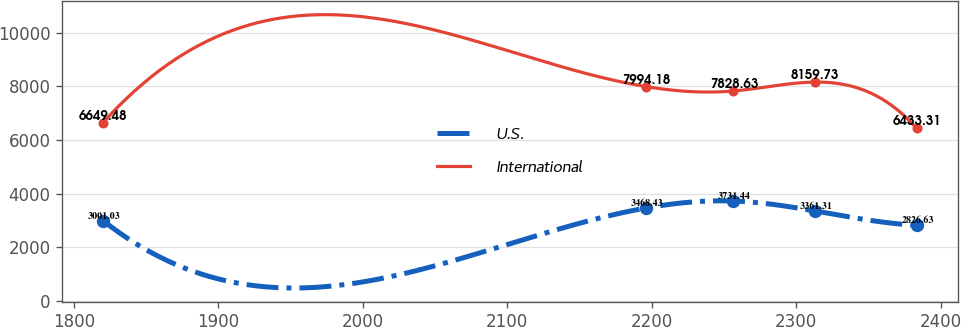<chart> <loc_0><loc_0><loc_500><loc_500><line_chart><ecel><fcel>U.S.<fcel>International<nl><fcel>1820.2<fcel>3001.03<fcel>6649.48<nl><fcel>2195.85<fcel>3468.43<fcel>7994.18<nl><fcel>2256.57<fcel>3731.44<fcel>7828.63<nl><fcel>2312.91<fcel>3361.31<fcel>8159.73<nl><fcel>2383.55<fcel>2826.63<fcel>6433.31<nl></chart> 